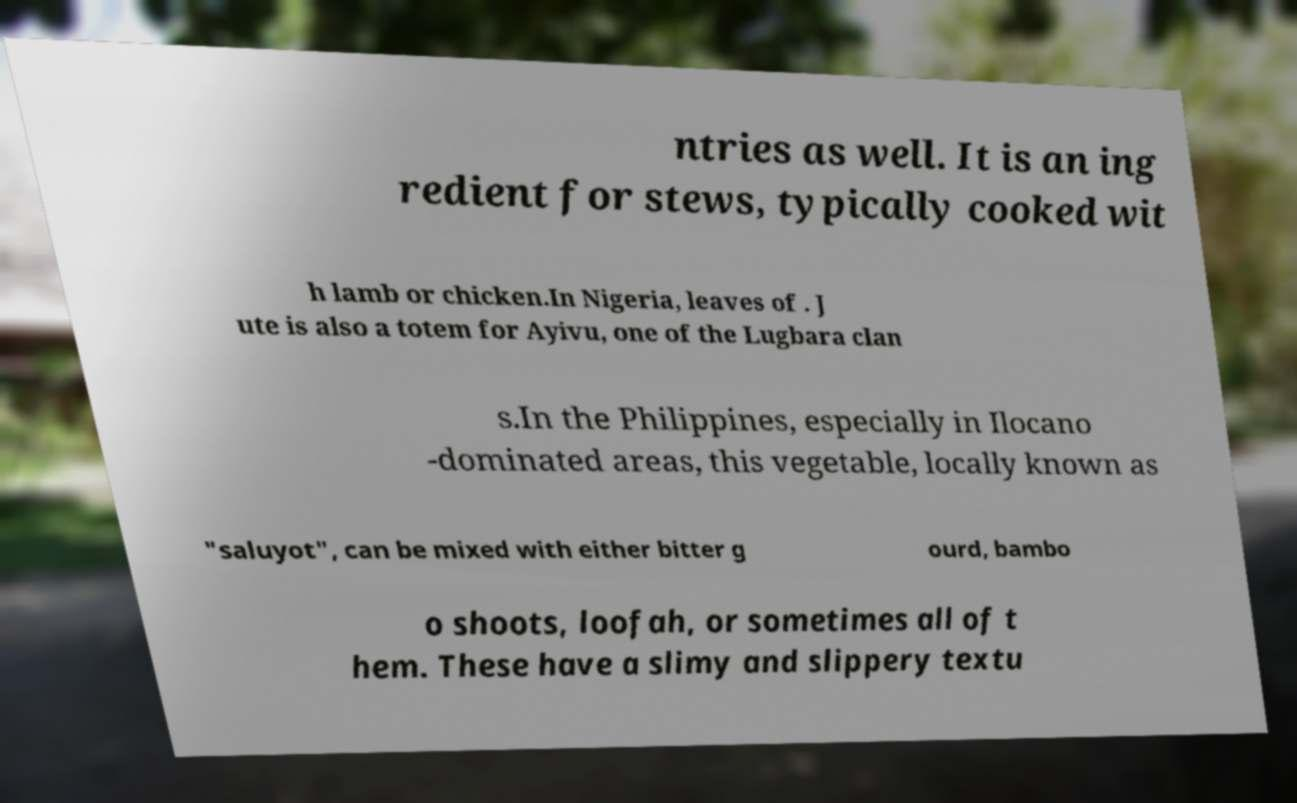For documentation purposes, I need the text within this image transcribed. Could you provide that? ntries as well. It is an ing redient for stews, typically cooked wit h lamb or chicken.In Nigeria, leaves of . J ute is also a totem for Ayivu, one of the Lugbara clan s.In the Philippines, especially in Ilocano -dominated areas, this vegetable, locally known as "saluyot", can be mixed with either bitter g ourd, bambo o shoots, loofah, or sometimes all of t hem. These have a slimy and slippery textu 